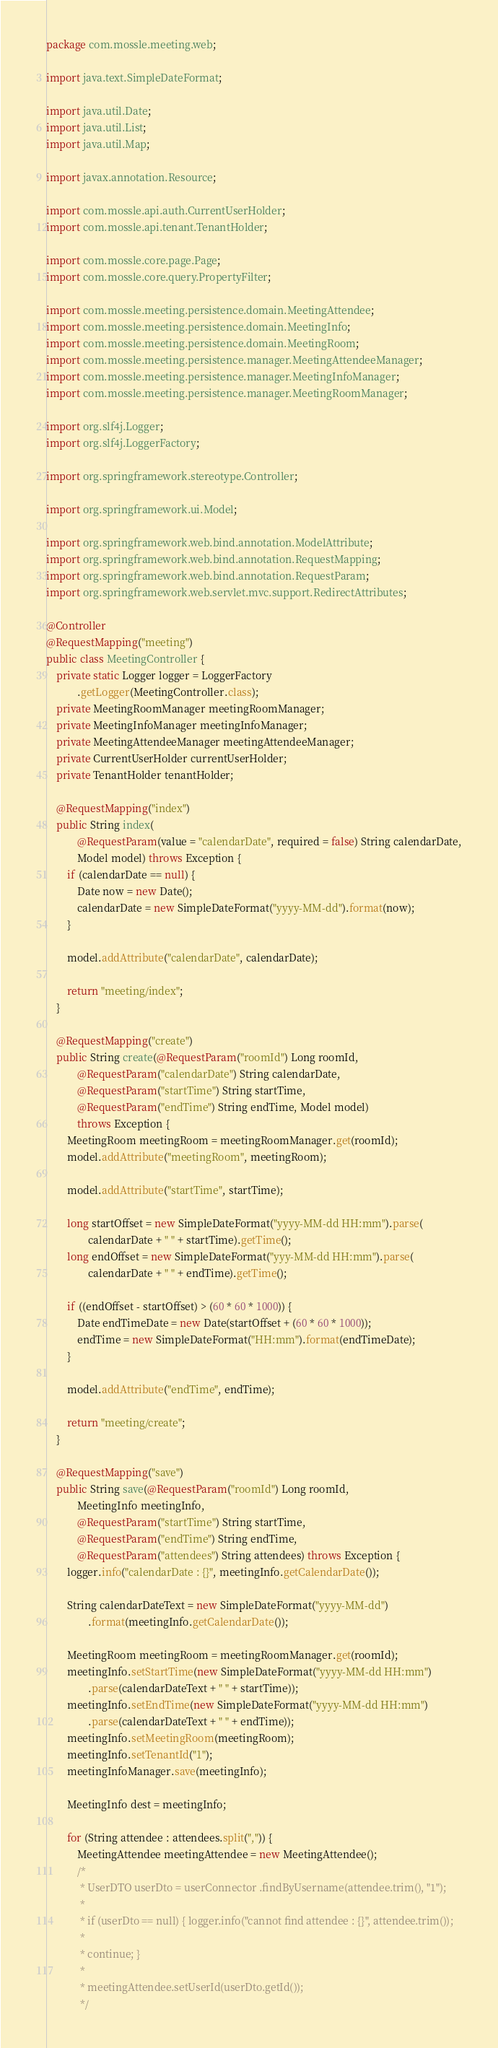Convert code to text. <code><loc_0><loc_0><loc_500><loc_500><_Java_>package com.mossle.meeting.web;

import java.text.SimpleDateFormat;

import java.util.Date;
import java.util.List;
import java.util.Map;

import javax.annotation.Resource;

import com.mossle.api.auth.CurrentUserHolder;
import com.mossle.api.tenant.TenantHolder;

import com.mossle.core.page.Page;
import com.mossle.core.query.PropertyFilter;

import com.mossle.meeting.persistence.domain.MeetingAttendee;
import com.mossle.meeting.persistence.domain.MeetingInfo;
import com.mossle.meeting.persistence.domain.MeetingRoom;
import com.mossle.meeting.persistence.manager.MeetingAttendeeManager;
import com.mossle.meeting.persistence.manager.MeetingInfoManager;
import com.mossle.meeting.persistence.manager.MeetingRoomManager;

import org.slf4j.Logger;
import org.slf4j.LoggerFactory;

import org.springframework.stereotype.Controller;

import org.springframework.ui.Model;

import org.springframework.web.bind.annotation.ModelAttribute;
import org.springframework.web.bind.annotation.RequestMapping;
import org.springframework.web.bind.annotation.RequestParam;
import org.springframework.web.servlet.mvc.support.RedirectAttributes;

@Controller
@RequestMapping("meeting")
public class MeetingController {
    private static Logger logger = LoggerFactory
            .getLogger(MeetingController.class);
    private MeetingRoomManager meetingRoomManager;
    private MeetingInfoManager meetingInfoManager;
    private MeetingAttendeeManager meetingAttendeeManager;
    private CurrentUserHolder currentUserHolder;
    private TenantHolder tenantHolder;

    @RequestMapping("index")
    public String index(
            @RequestParam(value = "calendarDate", required = false) String calendarDate,
            Model model) throws Exception {
        if (calendarDate == null) {
            Date now = new Date();
            calendarDate = new SimpleDateFormat("yyyy-MM-dd").format(now);
        }

        model.addAttribute("calendarDate", calendarDate);

        return "meeting/index";
    }

    @RequestMapping("create")
    public String create(@RequestParam("roomId") Long roomId,
            @RequestParam("calendarDate") String calendarDate,
            @RequestParam("startTime") String startTime,
            @RequestParam("endTime") String endTime, Model model)
            throws Exception {
        MeetingRoom meetingRoom = meetingRoomManager.get(roomId);
        model.addAttribute("meetingRoom", meetingRoom);

        model.addAttribute("startTime", startTime);

        long startOffset = new SimpleDateFormat("yyyy-MM-dd HH:mm").parse(
                calendarDate + " " + startTime).getTime();
        long endOffset = new SimpleDateFormat("yyy-MM-dd HH:mm").parse(
                calendarDate + " " + endTime).getTime();

        if ((endOffset - startOffset) > (60 * 60 * 1000)) {
            Date endTimeDate = new Date(startOffset + (60 * 60 * 1000));
            endTime = new SimpleDateFormat("HH:mm").format(endTimeDate);
        }

        model.addAttribute("endTime", endTime);

        return "meeting/create";
    }

    @RequestMapping("save")
    public String save(@RequestParam("roomId") Long roomId,
            MeetingInfo meetingInfo,
            @RequestParam("startTime") String startTime,
            @RequestParam("endTime") String endTime,
            @RequestParam("attendees") String attendees) throws Exception {
        logger.info("calendarDate : {}", meetingInfo.getCalendarDate());

        String calendarDateText = new SimpleDateFormat("yyyy-MM-dd")
                .format(meetingInfo.getCalendarDate());

        MeetingRoom meetingRoom = meetingRoomManager.get(roomId);
        meetingInfo.setStartTime(new SimpleDateFormat("yyyy-MM-dd HH:mm")
                .parse(calendarDateText + " " + startTime));
        meetingInfo.setEndTime(new SimpleDateFormat("yyyy-MM-dd HH:mm")
                .parse(calendarDateText + " " + endTime));
        meetingInfo.setMeetingRoom(meetingRoom);
        meetingInfo.setTenantId("1");
        meetingInfoManager.save(meetingInfo);

        MeetingInfo dest = meetingInfo;

        for (String attendee : attendees.split(",")) {
            MeetingAttendee meetingAttendee = new MeetingAttendee();
            /*
             * UserDTO userDto = userConnector .findByUsername(attendee.trim(), "1");
             * 
             * if (userDto == null) { logger.info("cannot find attendee : {}", attendee.trim());
             * 
             * continue; }
             * 
             * meetingAttendee.setUserId(userDto.getId());
             */</code> 